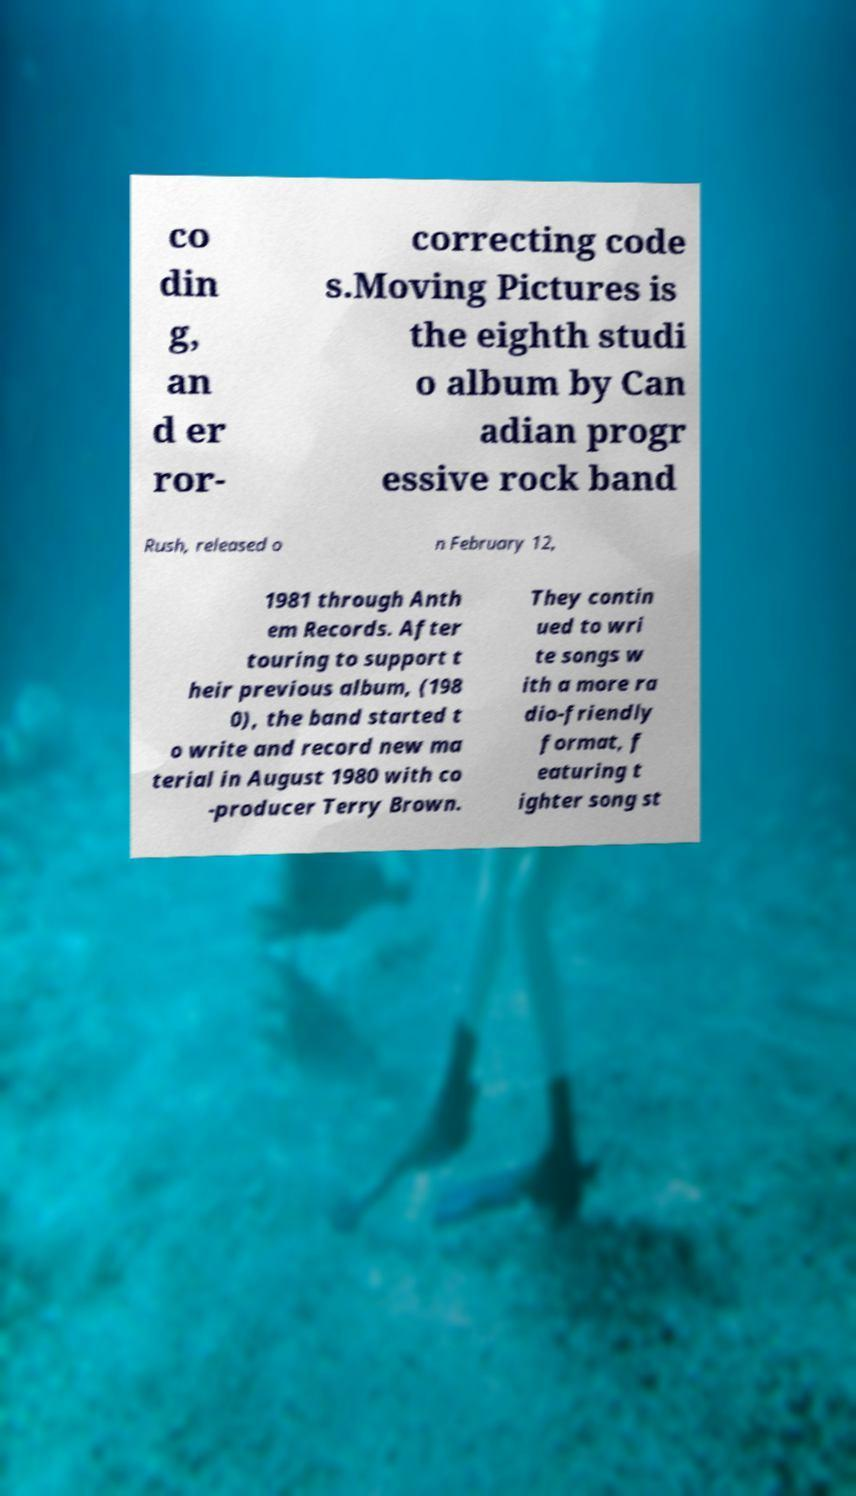Could you assist in decoding the text presented in this image and type it out clearly? co din g, an d er ror- correcting code s.Moving Pictures is the eighth studi o album by Can adian progr essive rock band Rush, released o n February 12, 1981 through Anth em Records. After touring to support t heir previous album, (198 0), the band started t o write and record new ma terial in August 1980 with co -producer Terry Brown. They contin ued to wri te songs w ith a more ra dio-friendly format, f eaturing t ighter song st 